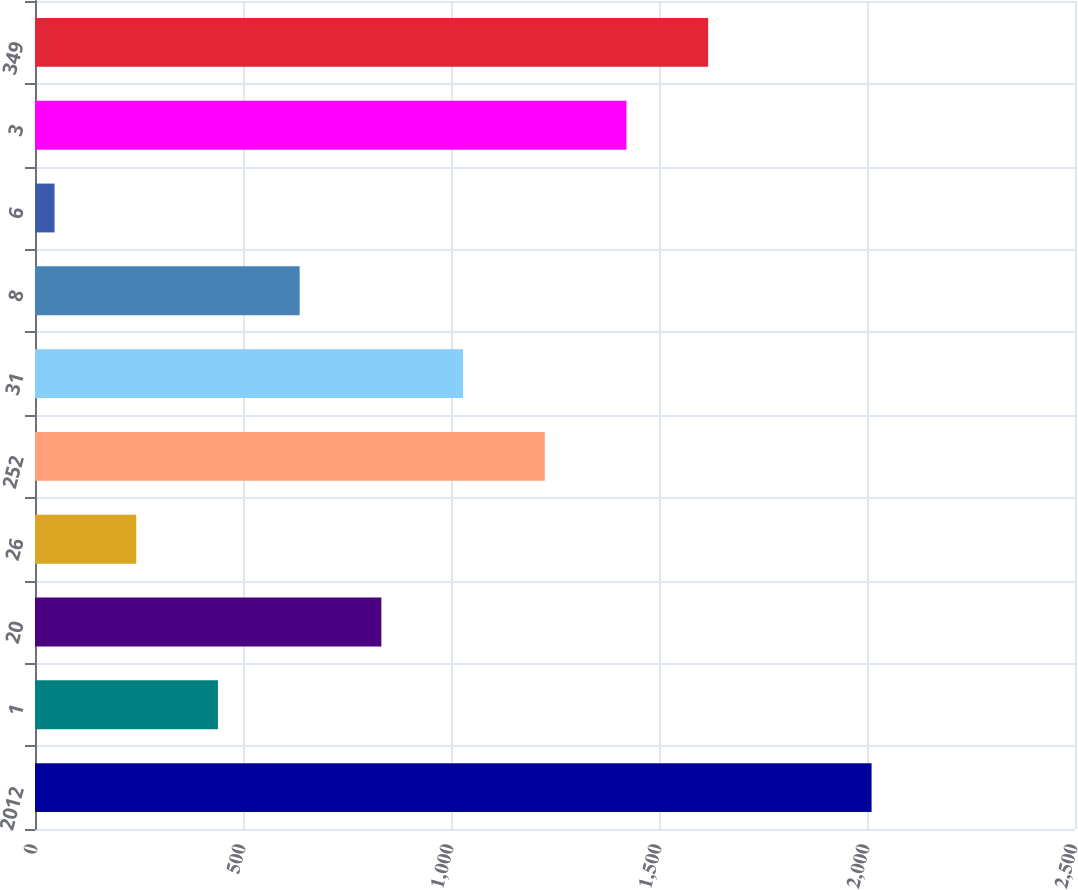Convert chart. <chart><loc_0><loc_0><loc_500><loc_500><bar_chart><fcel>2012<fcel>1<fcel>20<fcel>26<fcel>252<fcel>31<fcel>8<fcel>6<fcel>3<fcel>349<nl><fcel>2011<fcel>439.8<fcel>832.6<fcel>243.4<fcel>1225.4<fcel>1029<fcel>636.2<fcel>47<fcel>1421.8<fcel>1618.2<nl></chart> 